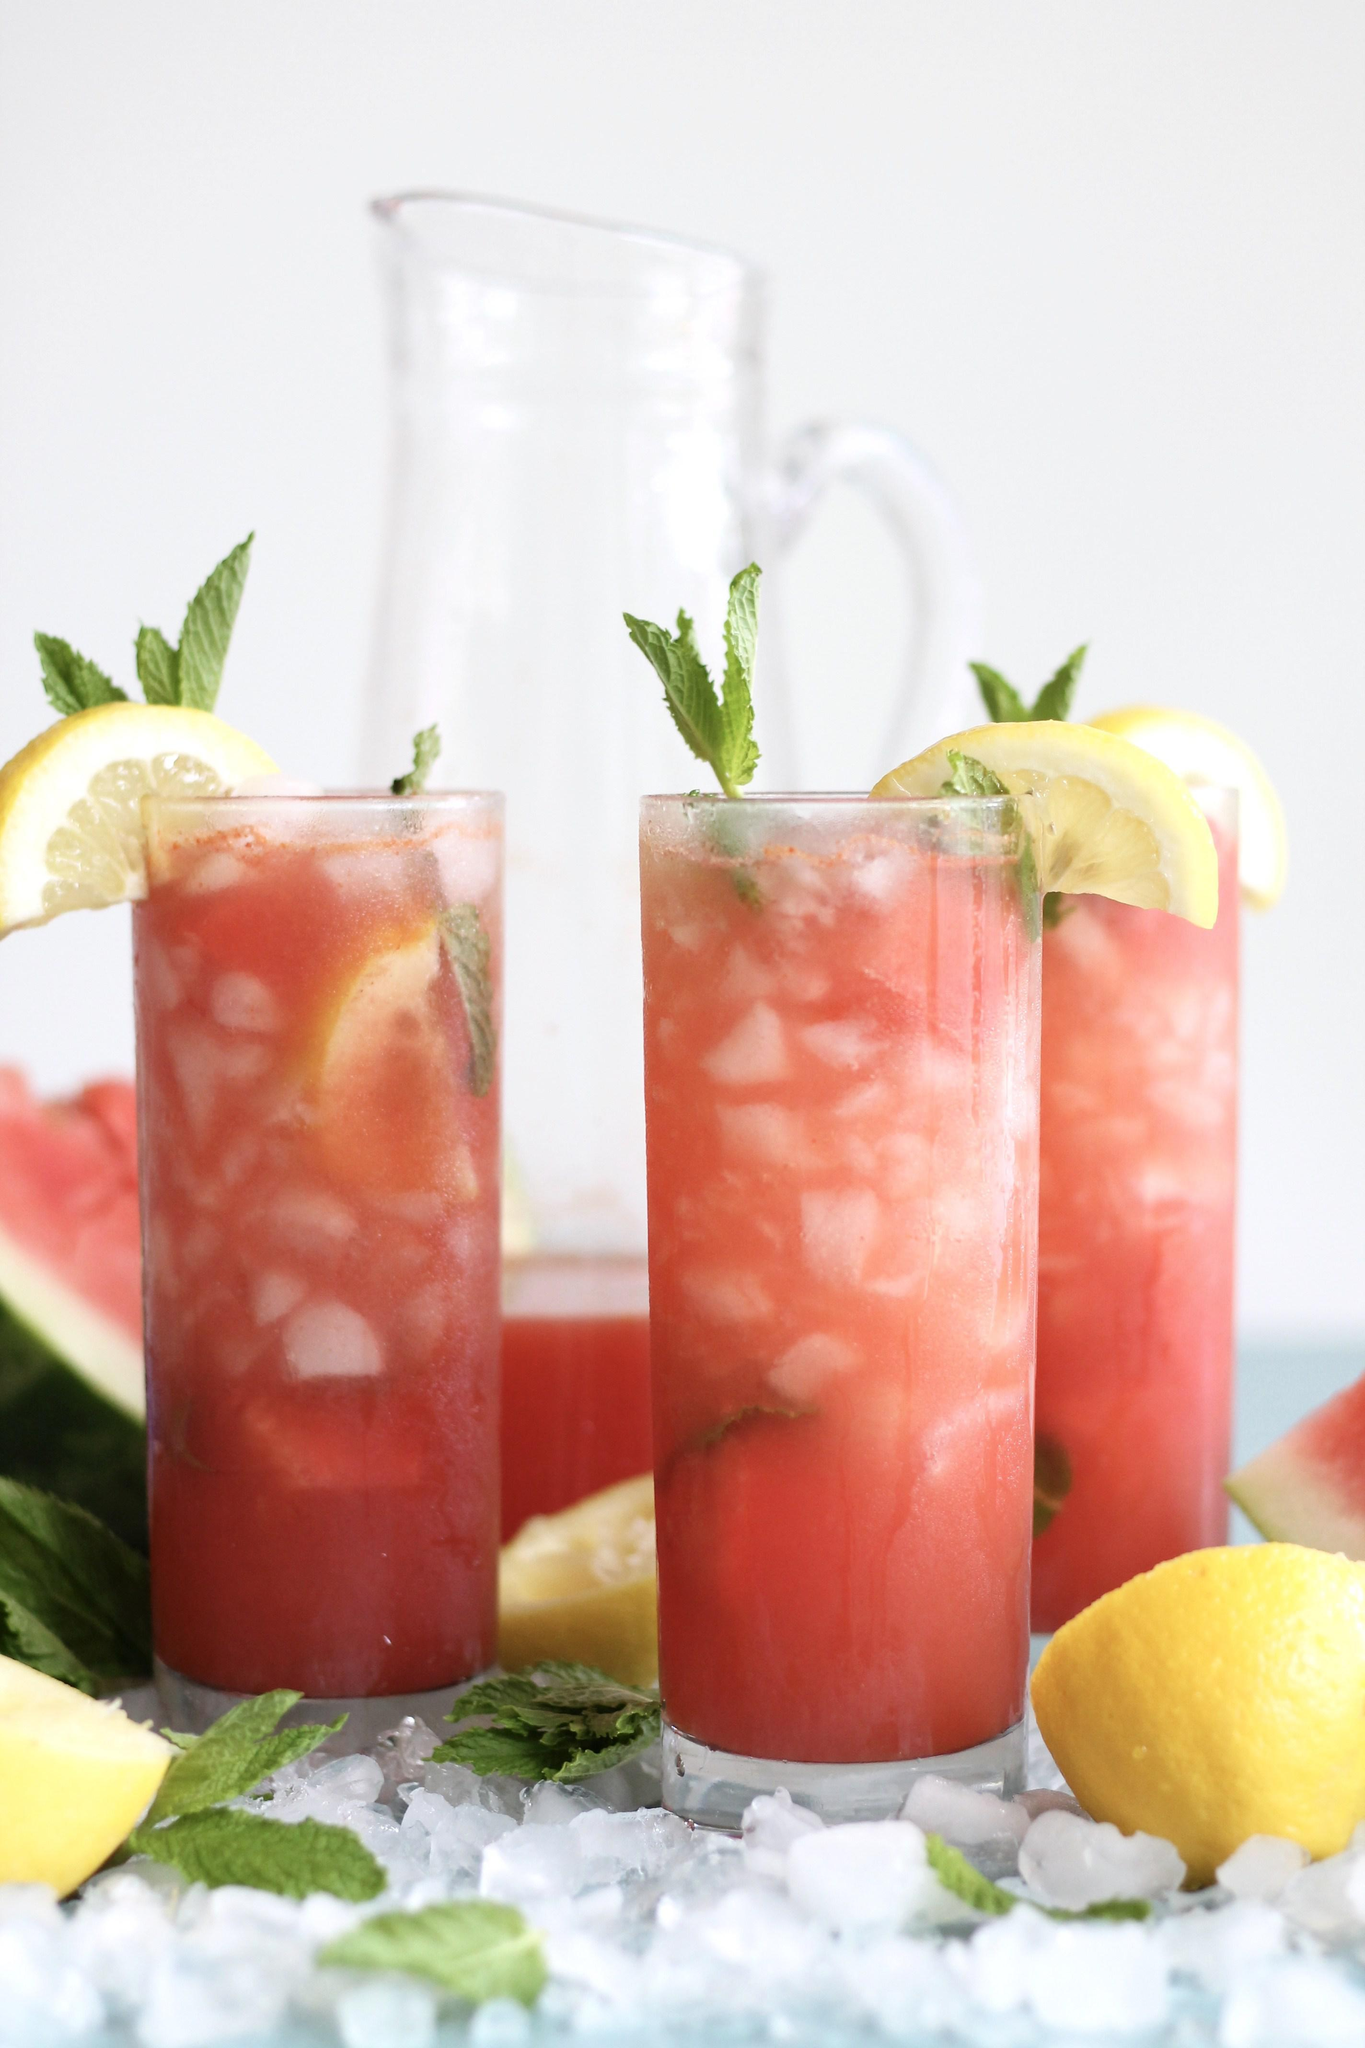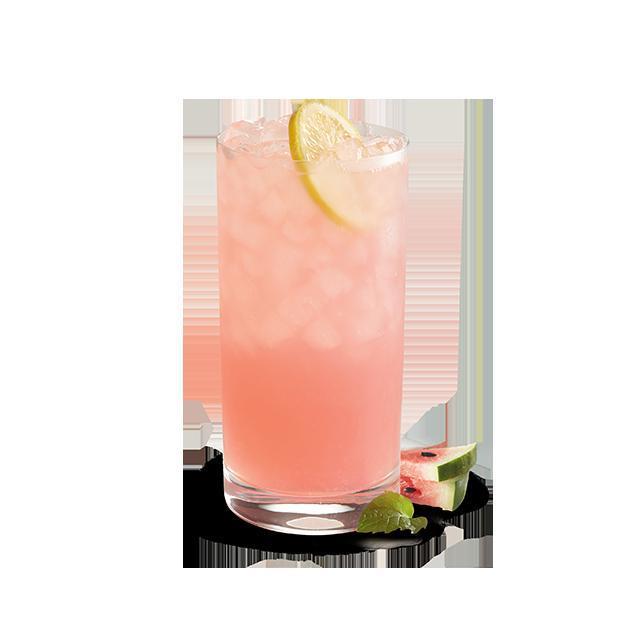The first image is the image on the left, the second image is the image on the right. For the images displayed, is the sentence "Exactly one prepared beverage glass is shown in each image." factually correct? Answer yes or no. No. 